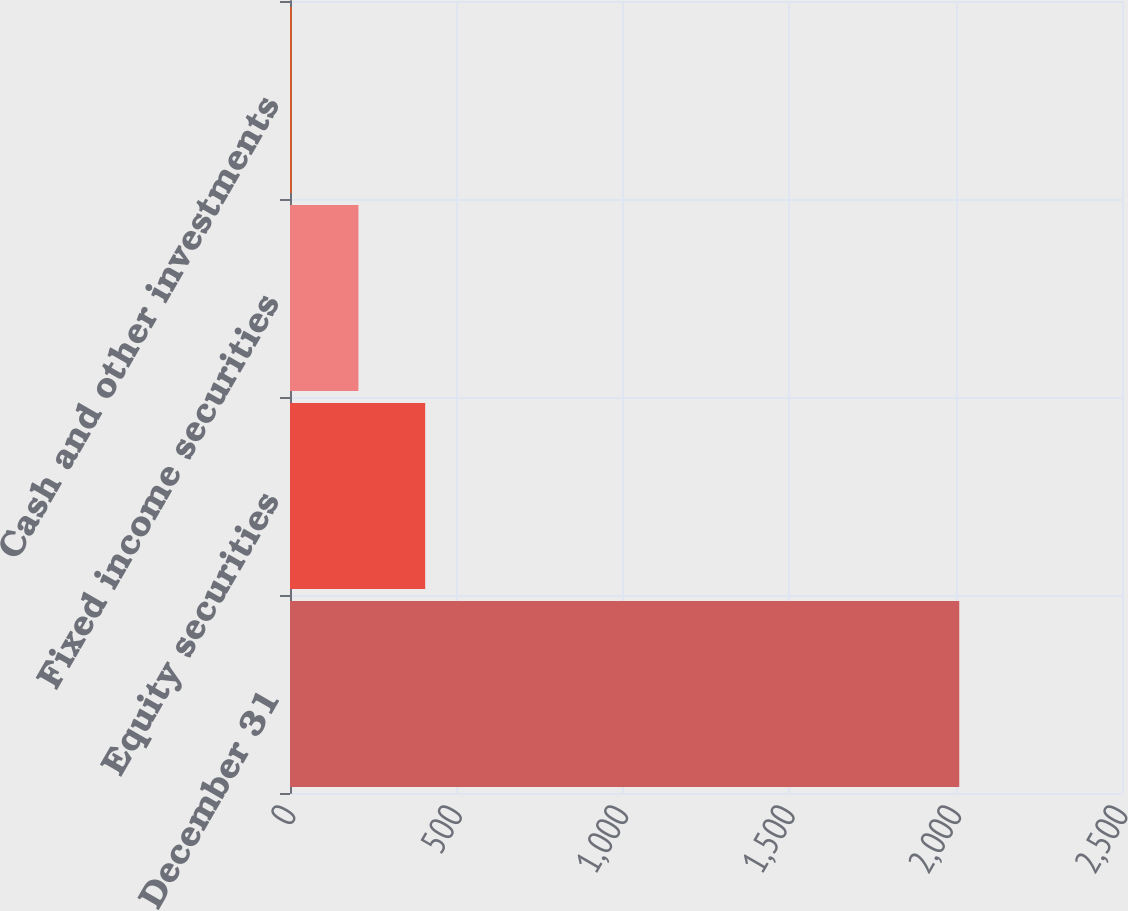<chart> <loc_0><loc_0><loc_500><loc_500><bar_chart><fcel>December 31<fcel>Equity securities<fcel>Fixed income securities<fcel>Cash and other investments<nl><fcel>2011<fcel>406.2<fcel>205.6<fcel>5<nl></chart> 